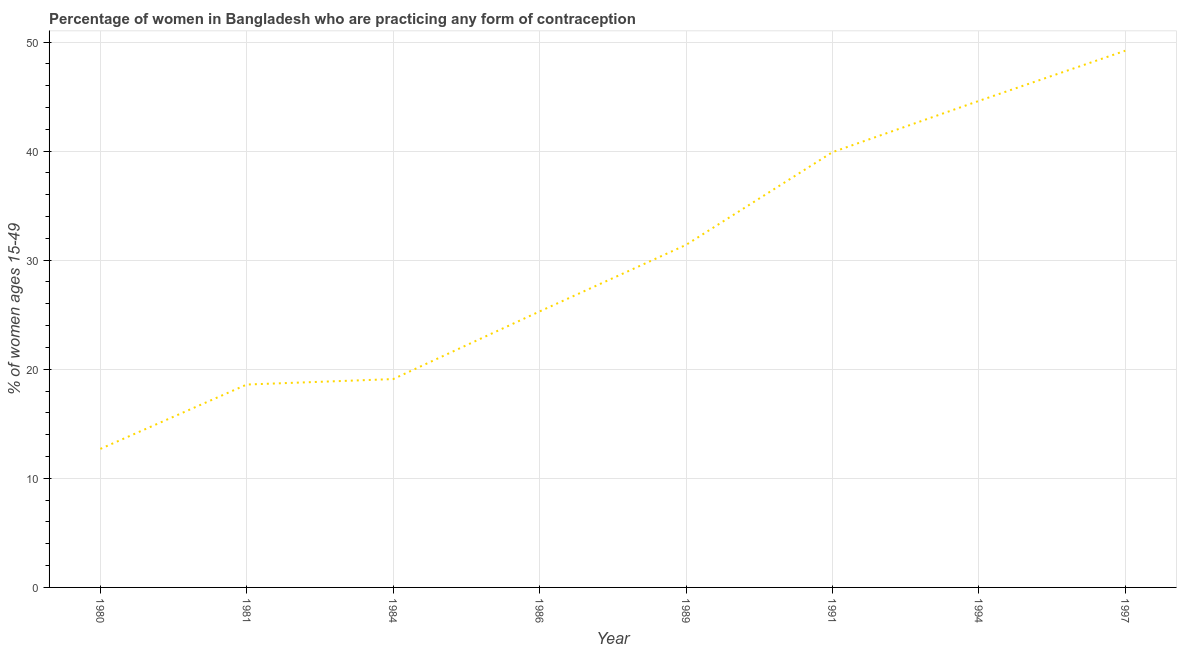Across all years, what is the maximum contraceptive prevalence?
Your answer should be very brief. 49.2. What is the sum of the contraceptive prevalence?
Make the answer very short. 240.8. What is the difference between the contraceptive prevalence in 1981 and 1991?
Make the answer very short. -21.3. What is the average contraceptive prevalence per year?
Ensure brevity in your answer.  30.1. What is the median contraceptive prevalence?
Give a very brief answer. 28.35. Do a majority of the years between 1980 and 1984 (inclusive) have contraceptive prevalence greater than 38 %?
Offer a very short reply. No. What is the ratio of the contraceptive prevalence in 1980 to that in 1981?
Give a very brief answer. 0.68. Is the difference between the contraceptive prevalence in 1991 and 1997 greater than the difference between any two years?
Provide a succinct answer. No. What is the difference between the highest and the second highest contraceptive prevalence?
Make the answer very short. 4.6. Is the sum of the contraceptive prevalence in 1980 and 1991 greater than the maximum contraceptive prevalence across all years?
Ensure brevity in your answer.  Yes. What is the difference between the highest and the lowest contraceptive prevalence?
Offer a very short reply. 36.5. In how many years, is the contraceptive prevalence greater than the average contraceptive prevalence taken over all years?
Provide a short and direct response. 4. Are the values on the major ticks of Y-axis written in scientific E-notation?
Give a very brief answer. No. Does the graph contain any zero values?
Your answer should be compact. No. Does the graph contain grids?
Your response must be concise. Yes. What is the title of the graph?
Provide a succinct answer. Percentage of women in Bangladesh who are practicing any form of contraception. What is the label or title of the Y-axis?
Your response must be concise. % of women ages 15-49. What is the % of women ages 15-49 of 1980?
Provide a short and direct response. 12.7. What is the % of women ages 15-49 of 1984?
Offer a very short reply. 19.1. What is the % of women ages 15-49 of 1986?
Ensure brevity in your answer.  25.3. What is the % of women ages 15-49 in 1989?
Offer a very short reply. 31.4. What is the % of women ages 15-49 of 1991?
Give a very brief answer. 39.9. What is the % of women ages 15-49 in 1994?
Make the answer very short. 44.6. What is the % of women ages 15-49 in 1997?
Provide a short and direct response. 49.2. What is the difference between the % of women ages 15-49 in 1980 and 1981?
Give a very brief answer. -5.9. What is the difference between the % of women ages 15-49 in 1980 and 1984?
Your answer should be very brief. -6.4. What is the difference between the % of women ages 15-49 in 1980 and 1989?
Your answer should be very brief. -18.7. What is the difference between the % of women ages 15-49 in 1980 and 1991?
Keep it short and to the point. -27.2. What is the difference between the % of women ages 15-49 in 1980 and 1994?
Provide a succinct answer. -31.9. What is the difference between the % of women ages 15-49 in 1980 and 1997?
Offer a terse response. -36.5. What is the difference between the % of women ages 15-49 in 1981 and 1984?
Your answer should be compact. -0.5. What is the difference between the % of women ages 15-49 in 1981 and 1986?
Give a very brief answer. -6.7. What is the difference between the % of women ages 15-49 in 1981 and 1989?
Keep it short and to the point. -12.8. What is the difference between the % of women ages 15-49 in 1981 and 1991?
Provide a succinct answer. -21.3. What is the difference between the % of women ages 15-49 in 1981 and 1997?
Keep it short and to the point. -30.6. What is the difference between the % of women ages 15-49 in 1984 and 1986?
Keep it short and to the point. -6.2. What is the difference between the % of women ages 15-49 in 1984 and 1989?
Make the answer very short. -12.3. What is the difference between the % of women ages 15-49 in 1984 and 1991?
Provide a short and direct response. -20.8. What is the difference between the % of women ages 15-49 in 1984 and 1994?
Give a very brief answer. -25.5. What is the difference between the % of women ages 15-49 in 1984 and 1997?
Offer a terse response. -30.1. What is the difference between the % of women ages 15-49 in 1986 and 1991?
Provide a short and direct response. -14.6. What is the difference between the % of women ages 15-49 in 1986 and 1994?
Ensure brevity in your answer.  -19.3. What is the difference between the % of women ages 15-49 in 1986 and 1997?
Your response must be concise. -23.9. What is the difference between the % of women ages 15-49 in 1989 and 1997?
Offer a very short reply. -17.8. What is the difference between the % of women ages 15-49 in 1994 and 1997?
Make the answer very short. -4.6. What is the ratio of the % of women ages 15-49 in 1980 to that in 1981?
Your answer should be compact. 0.68. What is the ratio of the % of women ages 15-49 in 1980 to that in 1984?
Your response must be concise. 0.67. What is the ratio of the % of women ages 15-49 in 1980 to that in 1986?
Make the answer very short. 0.5. What is the ratio of the % of women ages 15-49 in 1980 to that in 1989?
Your answer should be compact. 0.4. What is the ratio of the % of women ages 15-49 in 1980 to that in 1991?
Your answer should be very brief. 0.32. What is the ratio of the % of women ages 15-49 in 1980 to that in 1994?
Keep it short and to the point. 0.28. What is the ratio of the % of women ages 15-49 in 1980 to that in 1997?
Offer a very short reply. 0.26. What is the ratio of the % of women ages 15-49 in 1981 to that in 1984?
Keep it short and to the point. 0.97. What is the ratio of the % of women ages 15-49 in 1981 to that in 1986?
Keep it short and to the point. 0.73. What is the ratio of the % of women ages 15-49 in 1981 to that in 1989?
Keep it short and to the point. 0.59. What is the ratio of the % of women ages 15-49 in 1981 to that in 1991?
Offer a terse response. 0.47. What is the ratio of the % of women ages 15-49 in 1981 to that in 1994?
Your answer should be compact. 0.42. What is the ratio of the % of women ages 15-49 in 1981 to that in 1997?
Your answer should be very brief. 0.38. What is the ratio of the % of women ages 15-49 in 1984 to that in 1986?
Ensure brevity in your answer.  0.76. What is the ratio of the % of women ages 15-49 in 1984 to that in 1989?
Keep it short and to the point. 0.61. What is the ratio of the % of women ages 15-49 in 1984 to that in 1991?
Offer a very short reply. 0.48. What is the ratio of the % of women ages 15-49 in 1984 to that in 1994?
Your response must be concise. 0.43. What is the ratio of the % of women ages 15-49 in 1984 to that in 1997?
Offer a very short reply. 0.39. What is the ratio of the % of women ages 15-49 in 1986 to that in 1989?
Offer a very short reply. 0.81. What is the ratio of the % of women ages 15-49 in 1986 to that in 1991?
Offer a terse response. 0.63. What is the ratio of the % of women ages 15-49 in 1986 to that in 1994?
Provide a short and direct response. 0.57. What is the ratio of the % of women ages 15-49 in 1986 to that in 1997?
Provide a short and direct response. 0.51. What is the ratio of the % of women ages 15-49 in 1989 to that in 1991?
Keep it short and to the point. 0.79. What is the ratio of the % of women ages 15-49 in 1989 to that in 1994?
Ensure brevity in your answer.  0.7. What is the ratio of the % of women ages 15-49 in 1989 to that in 1997?
Provide a short and direct response. 0.64. What is the ratio of the % of women ages 15-49 in 1991 to that in 1994?
Provide a short and direct response. 0.9. What is the ratio of the % of women ages 15-49 in 1991 to that in 1997?
Your response must be concise. 0.81. What is the ratio of the % of women ages 15-49 in 1994 to that in 1997?
Provide a short and direct response. 0.91. 